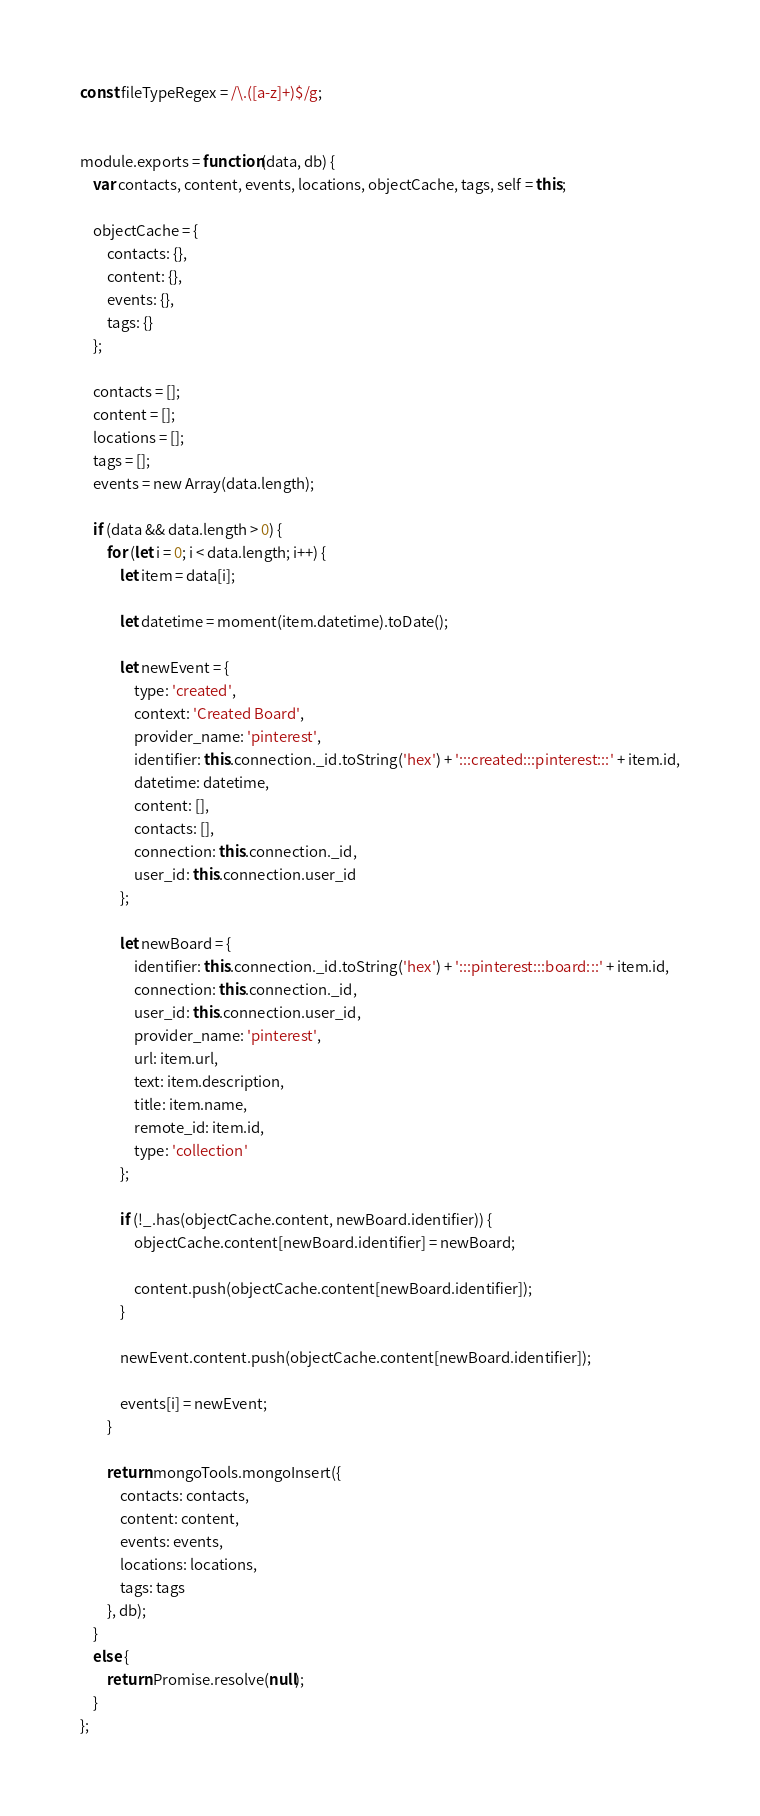<code> <loc_0><loc_0><loc_500><loc_500><_JavaScript_>
const fileTypeRegex = /\.([a-z]+)$/g;


module.exports = function(data, db) {
	var contacts, content, events, locations, objectCache, tags, self = this;

	objectCache = {
		contacts: {},
		content: {},
		events: {},
		tags: {}
	};

	contacts = [];
	content = [];
	locations = [];
	tags = [];
	events = new Array(data.length);

	if (data && data.length > 0) {
		for (let i = 0; i < data.length; i++) {
			let item = data[i];

			let datetime = moment(item.datetime).toDate();

			let newEvent = {
				type: 'created',
				context: 'Created Board',
				provider_name: 'pinterest',
				identifier: this.connection._id.toString('hex') + ':::created:::pinterest:::' + item.id,
				datetime: datetime,
				content: [],
				contacts: [],
				connection: this.connection._id,
				user_id: this.connection.user_id
			};

			let newBoard = {
				identifier: this.connection._id.toString('hex') + ':::pinterest:::board:::' + item.id,
				connection: this.connection._id,
				user_id: this.connection.user_id,
				provider_name: 'pinterest',
				url: item.url,
				text: item.description,
				title: item.name,
				remote_id: item.id,
				type: 'collection'
			};

			if (!_.has(objectCache.content, newBoard.identifier)) {
				objectCache.content[newBoard.identifier] = newBoard;

				content.push(objectCache.content[newBoard.identifier]);
			}

			newEvent.content.push(objectCache.content[newBoard.identifier]);

			events[i] = newEvent;
		}

		return mongoTools.mongoInsert({
			contacts: contacts,
			content: content,
			events: events,
			locations: locations,
			tags: tags
		}, db);
	}
	else {
		return Promise.resolve(null);
	}
};
</code> 